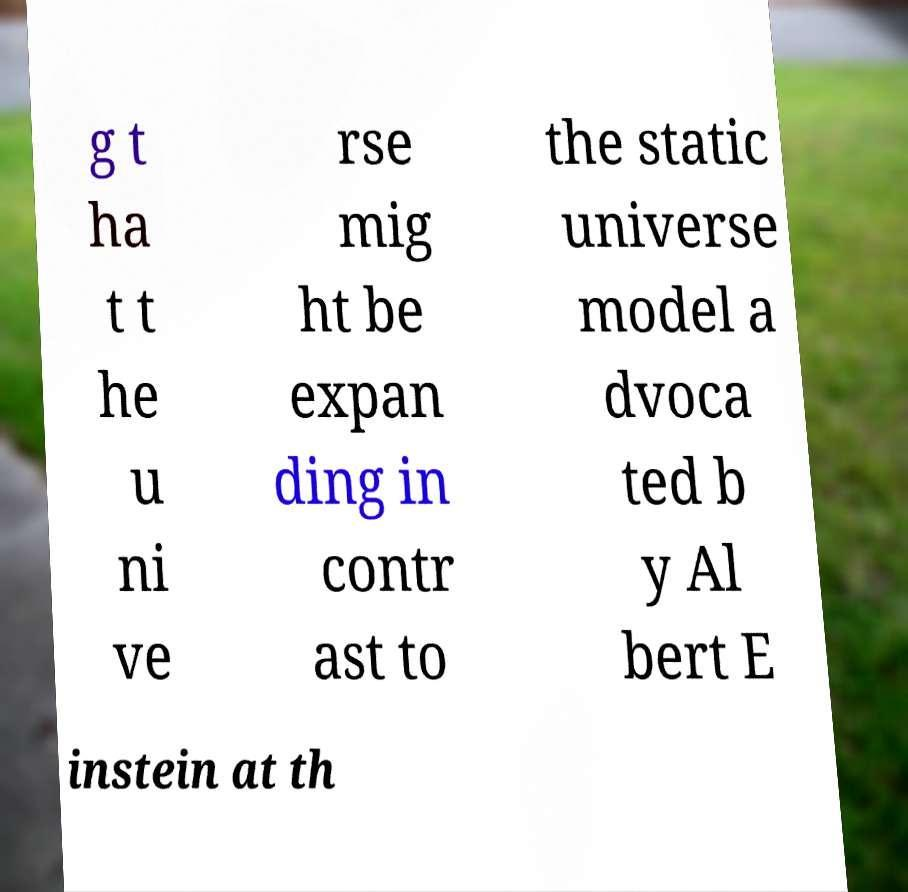Please identify and transcribe the text found in this image. g t ha t t he u ni ve rse mig ht be expan ding in contr ast to the static universe model a dvoca ted b y Al bert E instein at th 